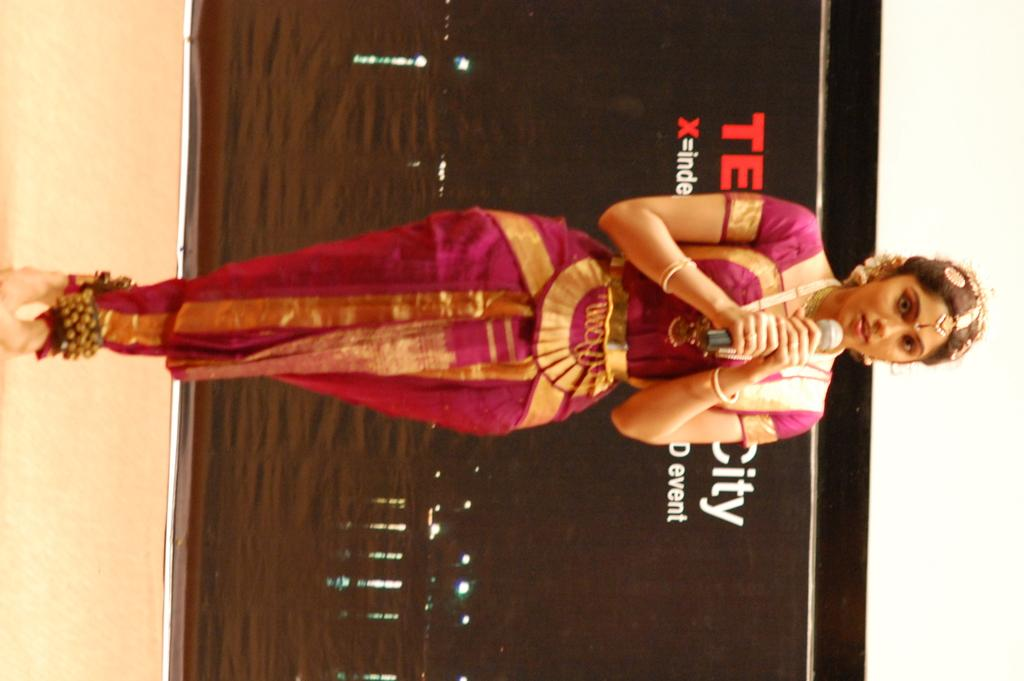What is the woman in the image doing? The woman is standing in the image and holding a microphone. What is the woman wearing in the image? The woman is wearing a fancy dress and jewelry. What can be seen in the background of the image? There is a hoarding with letters on it in the background. Can you tell me how many geese are in the woman's jewelry in the image? There are no geese present in the woman's jewelry or in the image. Is the woman in jail in the image? There is no indication in the image that the woman is in jail. 